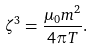<formula> <loc_0><loc_0><loc_500><loc_500>\zeta ^ { 3 } = \frac { \mu _ { 0 } m ^ { 2 } } { 4 \pi T } .</formula> 